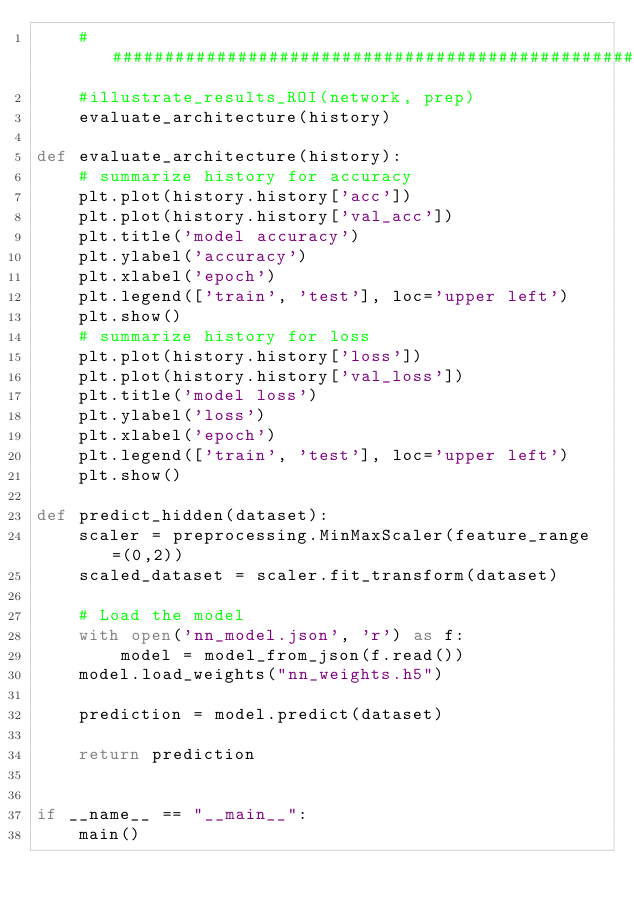Convert code to text. <code><loc_0><loc_0><loc_500><loc_500><_Python_>    #######################################################################
    #illustrate_results_ROI(network, prep)
    evaluate_architecture(history)

def evaluate_architecture(history):
    # summarize history for accuracy
    plt.plot(history.history['acc'])
    plt.plot(history.history['val_acc'])
    plt.title('model accuracy')
    plt.ylabel('accuracy')
    plt.xlabel('epoch')
    plt.legend(['train', 'test'], loc='upper left')
    plt.show()
    # summarize history for loss
    plt.plot(history.history['loss'])
    plt.plot(history.history['val_loss'])
    plt.title('model loss')
    plt.ylabel('loss')
    plt.xlabel('epoch')
    plt.legend(['train', 'test'], loc='upper left')
    plt.show()

def predict_hidden(dataset):
    scaler = preprocessing.MinMaxScaler(feature_range=(0,2))
    scaled_dataset = scaler.fit_transform(dataset)
    
    # Load the model
    with open('nn_model.json', 'r') as f:
        model = model_from_json(f.read())
    model.load_weights("nn_weights.h5")

    prediction = model.predict(dataset)

    return prediction


if __name__ == "__main__":
    main()
</code> 